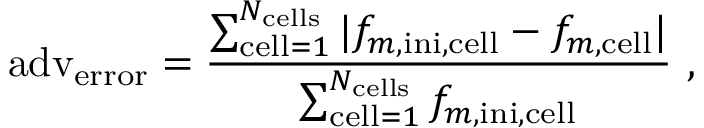<formula> <loc_0><loc_0><loc_500><loc_500>a d v _ { e r r o r } = \frac { \sum _ { c e l l = 1 } ^ { N _ { c e l l s } } | f _ { m , i n i , c e l l } - f _ { m , c e l l } | } { \sum _ { c e l l = 1 } ^ { N _ { c e l l s } } f _ { m , i n i , c e l l } } ,</formula> 